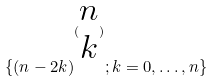<formula> <loc_0><loc_0><loc_500><loc_500>\{ ( n - 2 k ) ^ { ( \begin{matrix} n \\ k \end{matrix} ) } ; k = 0 , \dots , n \}</formula> 